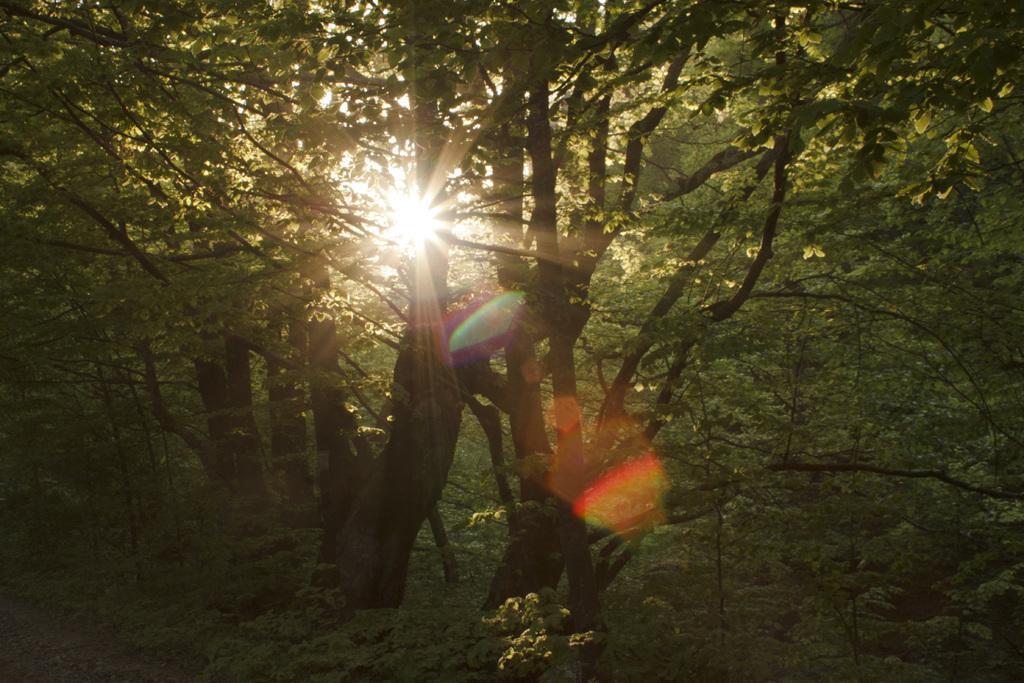Can you describe this image briefly? In this picture there are trees. In the center of the picture it is sun shining. 